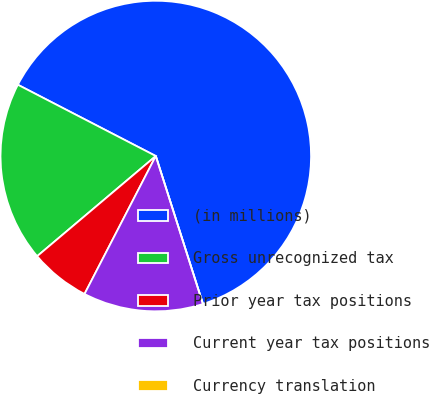<chart> <loc_0><loc_0><loc_500><loc_500><pie_chart><fcel>(in millions)<fcel>Gross unrecognized tax<fcel>Prior year tax positions<fcel>Current year tax positions<fcel>Currency translation<nl><fcel>62.49%<fcel>18.75%<fcel>6.25%<fcel>12.5%<fcel>0.0%<nl></chart> 